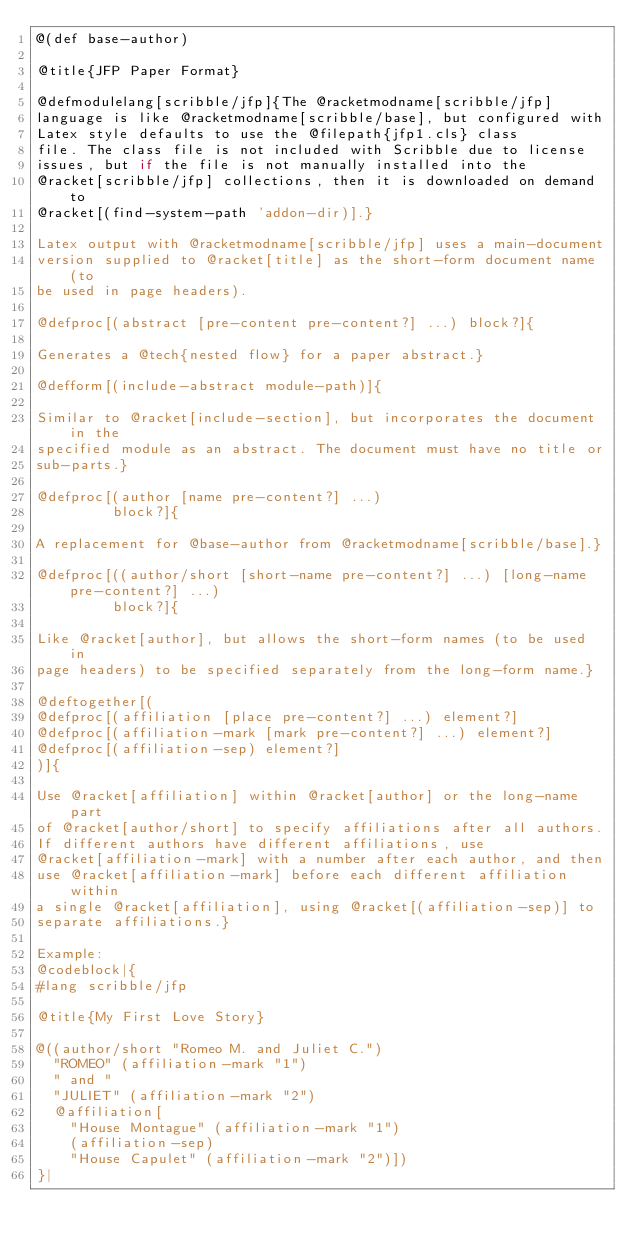Convert code to text. <code><loc_0><loc_0><loc_500><loc_500><_Racket_>@(def base-author)

@title{JFP Paper Format}

@defmodulelang[scribble/jfp]{The @racketmodname[scribble/jfp]
language is like @racketmodname[scribble/base], but configured with
Latex style defaults to use the @filepath{jfp1.cls} class
file. The class file is not included with Scribble due to license
issues, but if the file is not manually installed into the
@racket[scribble/jfp] collections, then it is downloaded on demand to
@racket[(find-system-path 'addon-dir)].}

Latex output with @racketmodname[scribble/jfp] uses a main-document
version supplied to @racket[title] as the short-form document name (to
be used in page headers).

@defproc[(abstract [pre-content pre-content?] ...) block?]{

Generates a @tech{nested flow} for a paper abstract.}

@defform[(include-abstract module-path)]{

Similar to @racket[include-section], but incorporates the document in the
specified module as an abstract. The document must have no title or
sub-parts.}

@defproc[(author [name pre-content?] ...)
         block?]{

A replacement for @base-author from @racketmodname[scribble/base].}

@defproc[((author/short [short-name pre-content?] ...) [long-name pre-content?] ...)
         block?]{

Like @racket[author], but allows the short-form names (to be used in
page headers) to be specified separately from the long-form name.}

@deftogether[(
@defproc[(affiliation [place pre-content?] ...) element?]
@defproc[(affiliation-mark [mark pre-content?] ...) element?]
@defproc[(affiliation-sep) element?]
)]{

Use @racket[affiliation] within @racket[author] or the long-name part
of @racket[author/short] to specify affiliations after all authors.
If different authors have different affiliations, use
@racket[affiliation-mark] with a number after each author, and then
use @racket[affiliation-mark] before each different affiliation within
a single @racket[affiliation], using @racket[(affiliation-sep)] to
separate affiliations.}

Example:
@codeblock|{
#lang scribble/jfp

@title{My First Love Story}

@((author/short "Romeo M. and Juliet C.")
  "ROMEO" (affiliation-mark "1")
  " and "
  "JULIET" (affiliation-mark "2")
  @affiliation[
    "House Montague" (affiliation-mark "1")
    (affiliation-sep)
    "House Capulet" (affiliation-mark "2")])
}|
</code> 